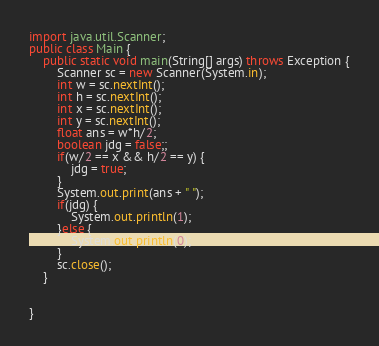Convert code to text. <code><loc_0><loc_0><loc_500><loc_500><_Java_>
import java.util.Scanner;
public class Main {
	public static void main(String[] args) throws Exception {
		Scanner sc = new Scanner(System.in);
		int w = sc.nextInt();
		int h = sc.nextInt();
		int x = sc.nextInt();
		int y = sc.nextInt();
		float ans = w*h/2;
		boolean jdg = false;;
		if(w/2 == x && h/2 == y) {
			jdg = true;
		}
		System.out.print(ans + " ");
		if(jdg) {
			System.out.println(1);
		}else {
			System.out.println(0);
		}
		sc.close();
	}


}
</code> 